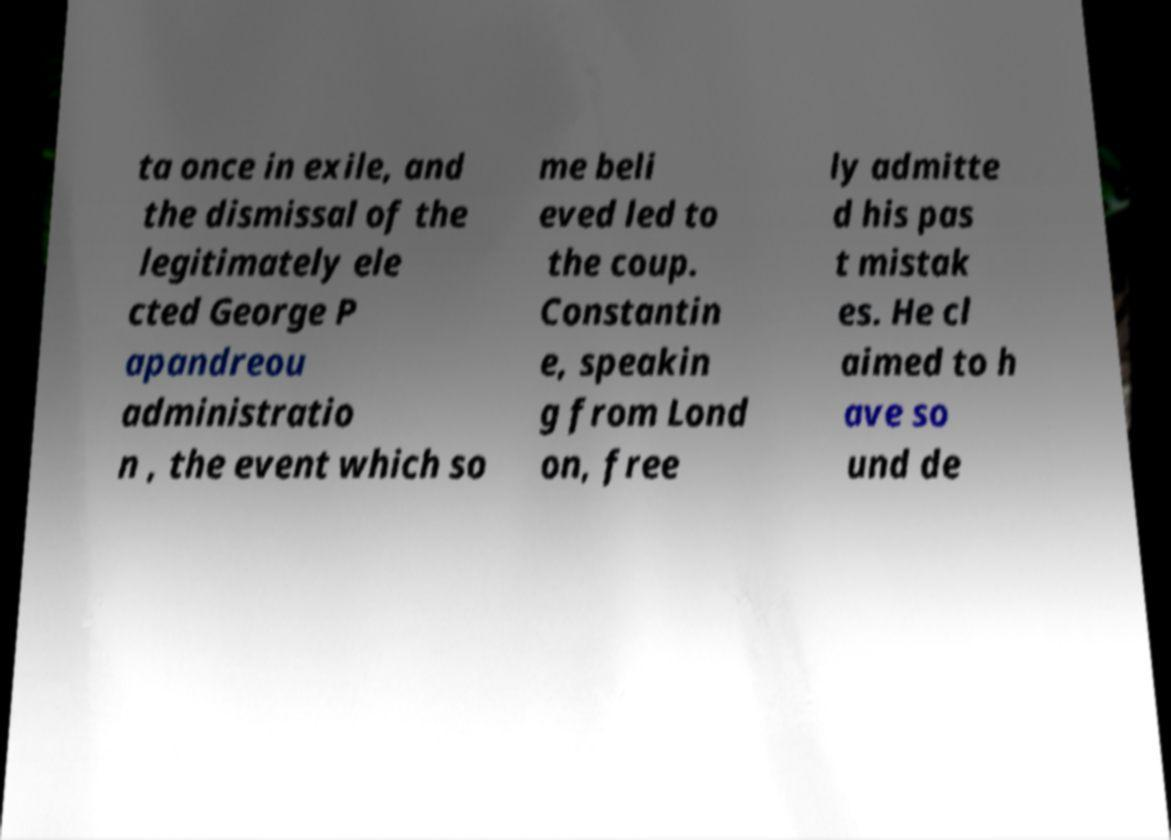Please read and relay the text visible in this image. What does it say? ta once in exile, and the dismissal of the legitimately ele cted George P apandreou administratio n , the event which so me beli eved led to the coup. Constantin e, speakin g from Lond on, free ly admitte d his pas t mistak es. He cl aimed to h ave so und de 